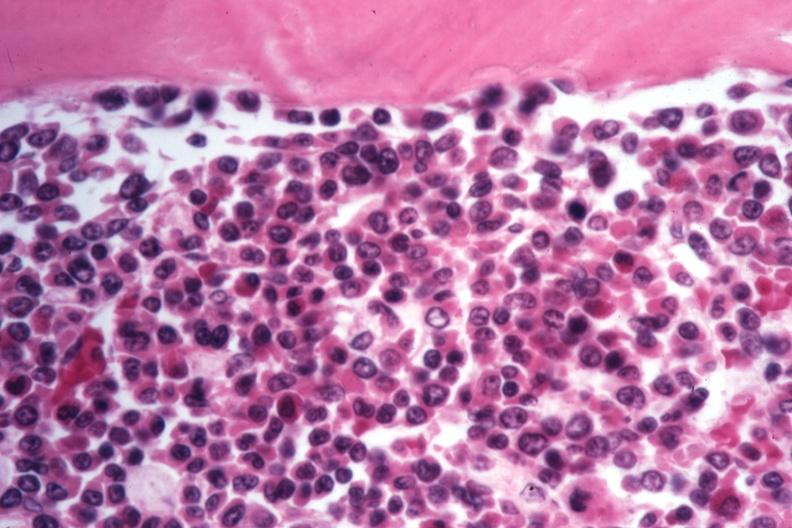what is present?
Answer the question using a single word or phrase. Bone marrow 